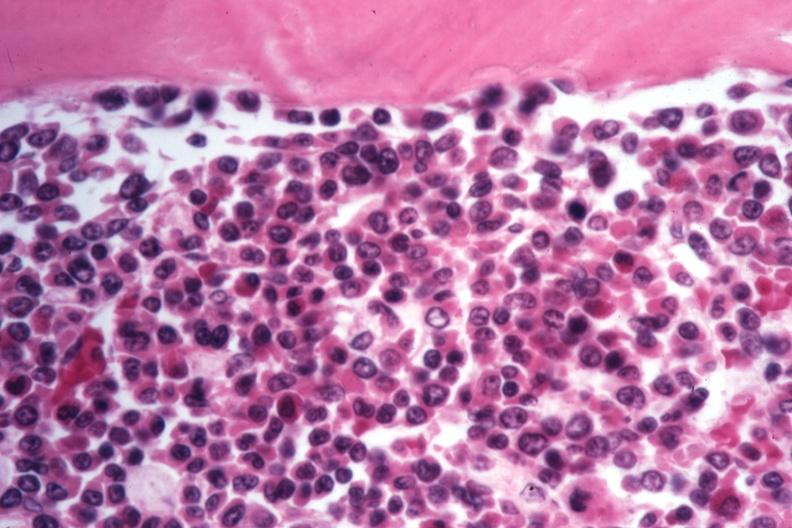what is present?
Answer the question using a single word or phrase. Bone marrow 